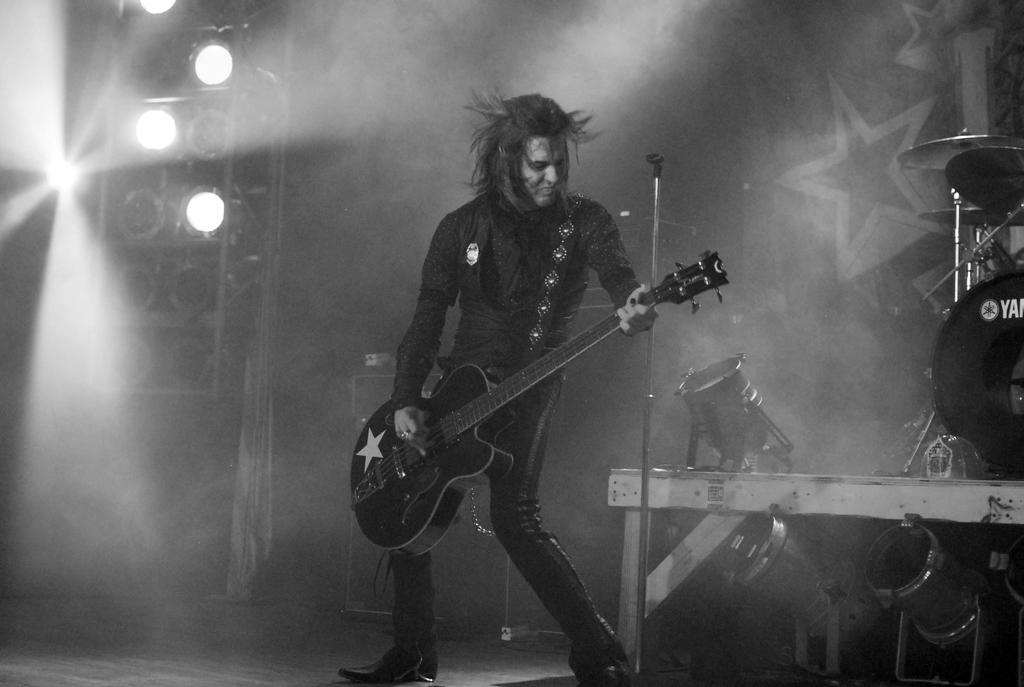What is the man in the image doing? The man is playing a guitar in the image. Where is the man located in the image? The man is on a stage in the image. What can be seen in the background of the image? There are lights in the image. What other objects are present in the image besides the guitar? There are musical instruments in the image. How many tomatoes are on the man's face in the image? There are no tomatoes present on the man's face in the image. What type of smile does the man have in the image? The provided facts do not mention the man's facial expression, so we cannot determine if he is smiling or not. 